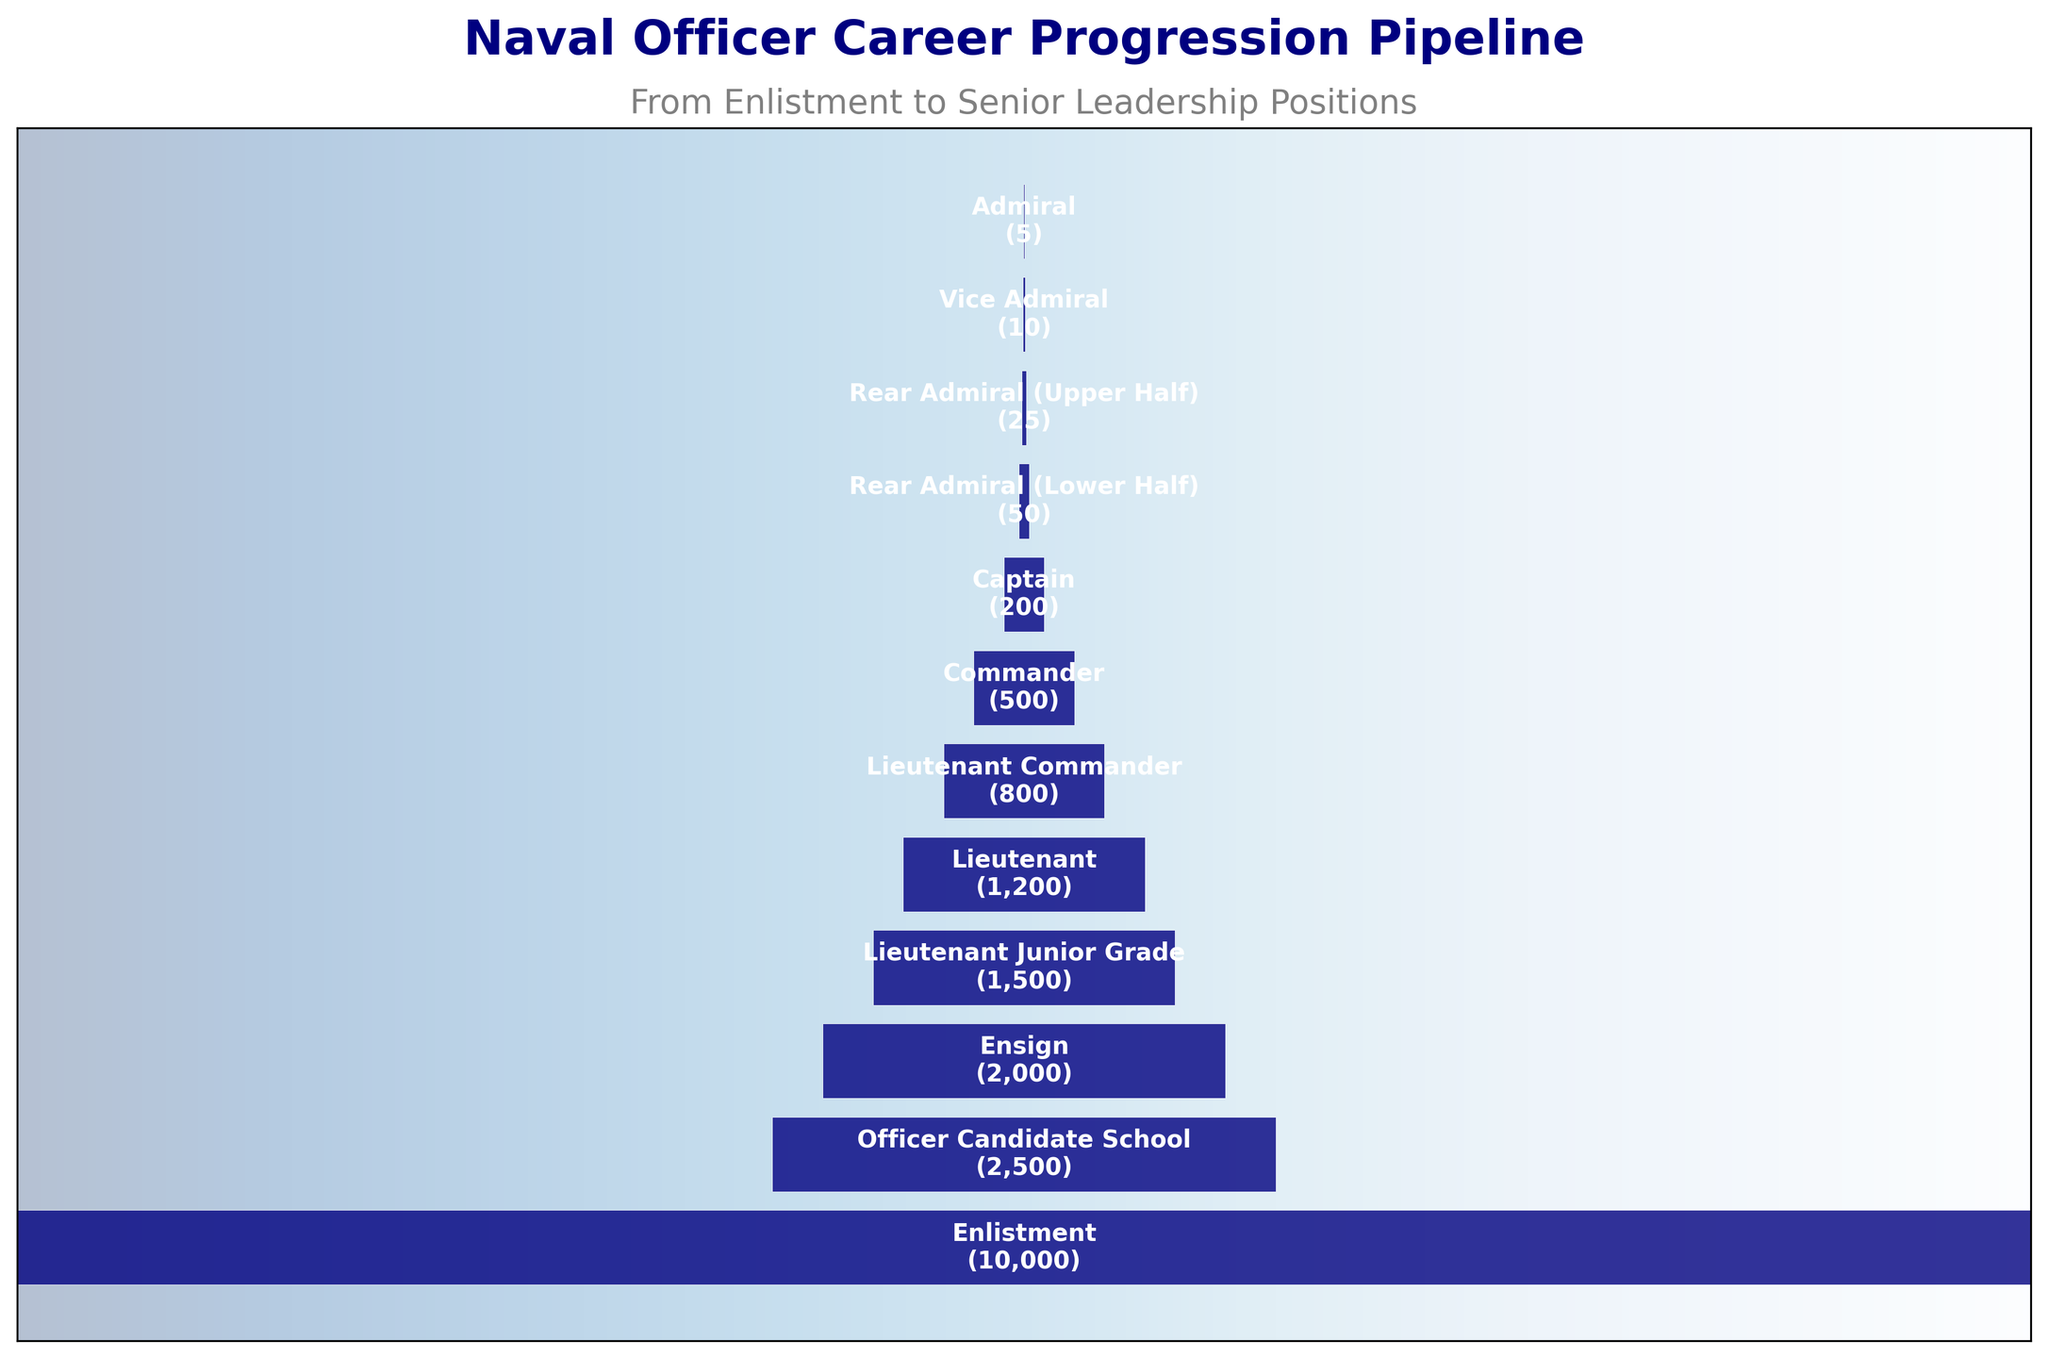What is the total number of personnel who reach the rank of Admiral? According to the funnel chart, the rank of Admiral is the last stage, and the number of personnel at this stage is 5.
Answer: 5 How many personnel move from Enlistment to Officer Candidate School? The Enlistment stage starts with 10,000 personnel, and the Officer Candidate School stage has 2,500 personnel. Subtracting the latter from the former gives us the number who moved: 10000 - 2500 = 7500.
Answer: 7500 Which stage sees the greatest drop in personnel numbers? The greatest drop is observed by comparing the number of personnel at each stage: 
Enlistment to Officer Candidate School: 10,000 - 2,500 = 7,500 
Officer Candidate School to Ensign: 2,500 - 2,000 = 500 
Ensign to Lieutenant Junior Grade: 2,000 - 1,500 = 500 
Lieutenant Junior Grade to Lieutenant: 1,500 - 1,200 = 300 
Lieutenant to Lieutenant Commander: 1,200 - 800 = 400 
Lieutenant Commander to Commander: 800 - 500 = 300 
Commander to Captain: 500 - 200 = 300 
Captain to Rear Admiral (Lower Half): 200 - 50 = 150 
Rear Admiral (Lower Half) to Rear Admiral (Upper Half): 50 - 25 = 25 
Rear Admiral (Upper Half) to Vice Admiral: 25 - 10 = 15 
Vice Admiral to Admiral: 10 - 5 = 5.
The greatest drop is from Enlistment to Officer Candidate School.
Answer: Enlistment to Officer Candidate School How many stages are there in the career progression pipeline? Counting each stage listed in the funnel chart from "Enlistment" to "Admiral", we get a total of 12 stages.
Answer: 12 What proportion of Ensigns make it to the rank of Captain? The number of personnel at the Ensign stage is 2,000 and the number at the Captain stage is 200. Therefore, the proportion is 200 / 2,000 = 0.1 or 10%.
Answer: 10% What is the percentage decrease in personnel from Rear Admiral (Lower Half) to Rear Admiral (Upper Half)? Rear Admiral (Lower Half) stage has 50 personnel, and Rear Admiral (Upper Half) has 25 personnel. The percentage decrease is calculated as: ((50 - 25) / 50) * 100 = 50%.
Answer: 50% How does the number of Lieutenant Commanders compare to the number of Vice Admirals? There are 800 Lieutenant Commanders and 10 Vice Admirals. 800 is significantly greater than 10.
Answer: 800 is greater than 10 What is the average number of personnel at the final three stages (Rear Admiral Lower Half, Rear Admiral Upper Half, Vice Admiral, and Admiral)? Adding personnel numbers at Rear Admiral (Lower Half), Rear Admiral (Upper Half), Vice Admiral, and Admiral: 50 + 25 + 10 + 5 = 90. The average is then 90 / 4 = 22.5.
Answer: 22.5 At which stage do personnel numbers fall below 1000 for the first time? From the funnel chart, personnel numbers first fall below 1000 at the Lieutenant Commander stage, which has 800 personnel.
Answer: Lieutenant Commander 